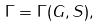<formula> <loc_0><loc_0><loc_500><loc_500>\Gamma = \Gamma ( G , S ) ,</formula> 